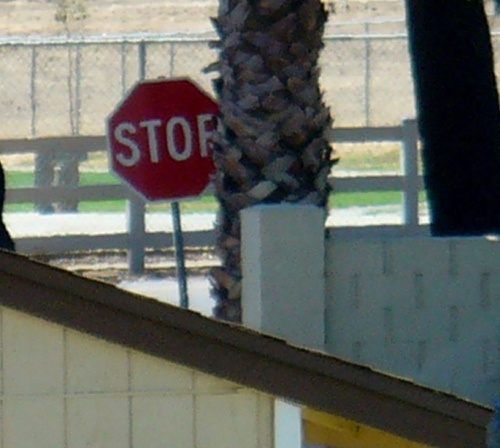Describe the objects in this image and their specific colors. I can see a stop sign in darkgray, maroon, gray, black, and purple tones in this image. 